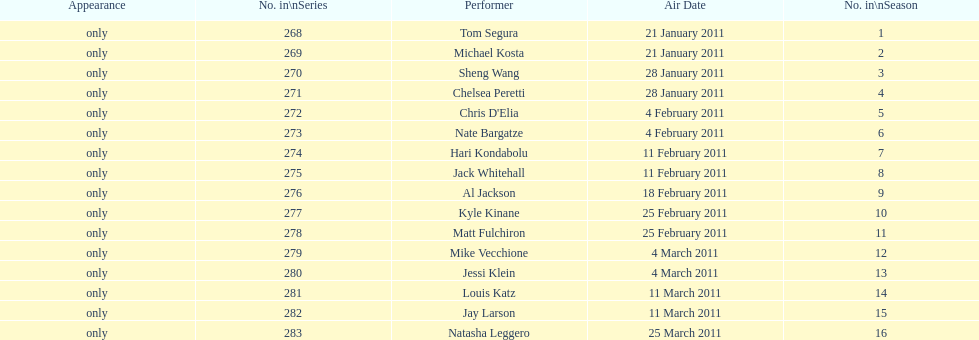What is the name of the last performer on this chart? Natasha Leggero. 